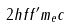<formula> <loc_0><loc_0><loc_500><loc_500>2 h f f ^ { \prime } m _ { e } c</formula> 